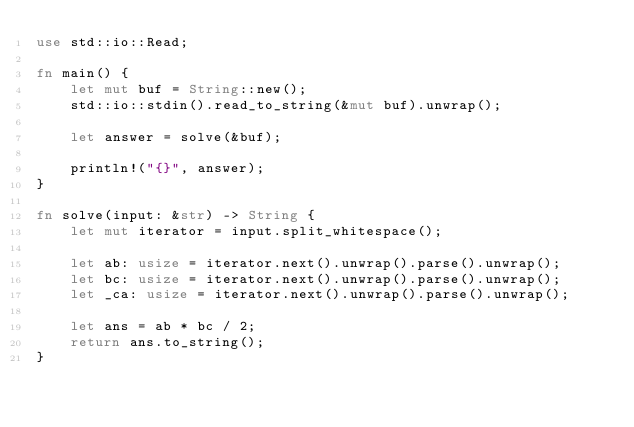<code> <loc_0><loc_0><loc_500><loc_500><_Rust_>use std::io::Read;

fn main() {
    let mut buf = String::new();
    std::io::stdin().read_to_string(&mut buf).unwrap();

    let answer = solve(&buf);

    println!("{}", answer);
}

fn solve(input: &str) -> String {
    let mut iterator = input.split_whitespace();

    let ab: usize = iterator.next().unwrap().parse().unwrap();
    let bc: usize = iterator.next().unwrap().parse().unwrap();
    let _ca: usize = iterator.next().unwrap().parse().unwrap();

    let ans = ab * bc / 2;
    return ans.to_string();
}
</code> 